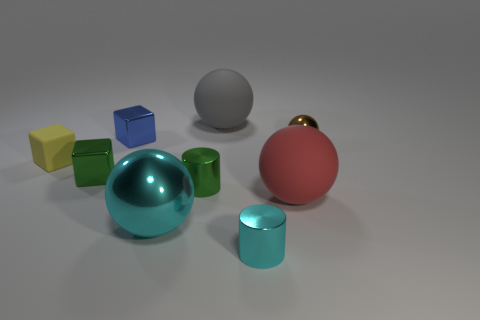Subtract all blocks. How many objects are left? 6 Subtract 0 purple cylinders. How many objects are left? 9 Subtract all large red rubber objects. Subtract all tiny metallic cylinders. How many objects are left? 6 Add 8 cyan shiny cylinders. How many cyan shiny cylinders are left? 9 Add 3 green metallic blocks. How many green metallic blocks exist? 4 